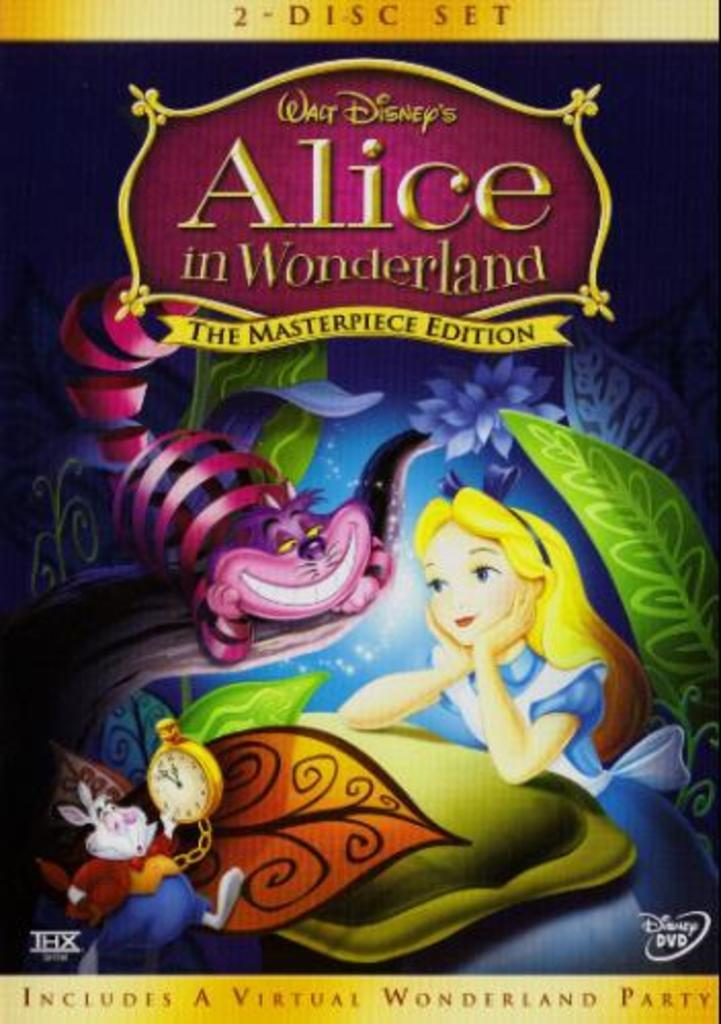<image>
Offer a succinct explanation of the picture presented. 2- Disc Set of Walt Disney's Alice in Wonderland the Masterpiece Edition which includes a virtual wonderland party. 